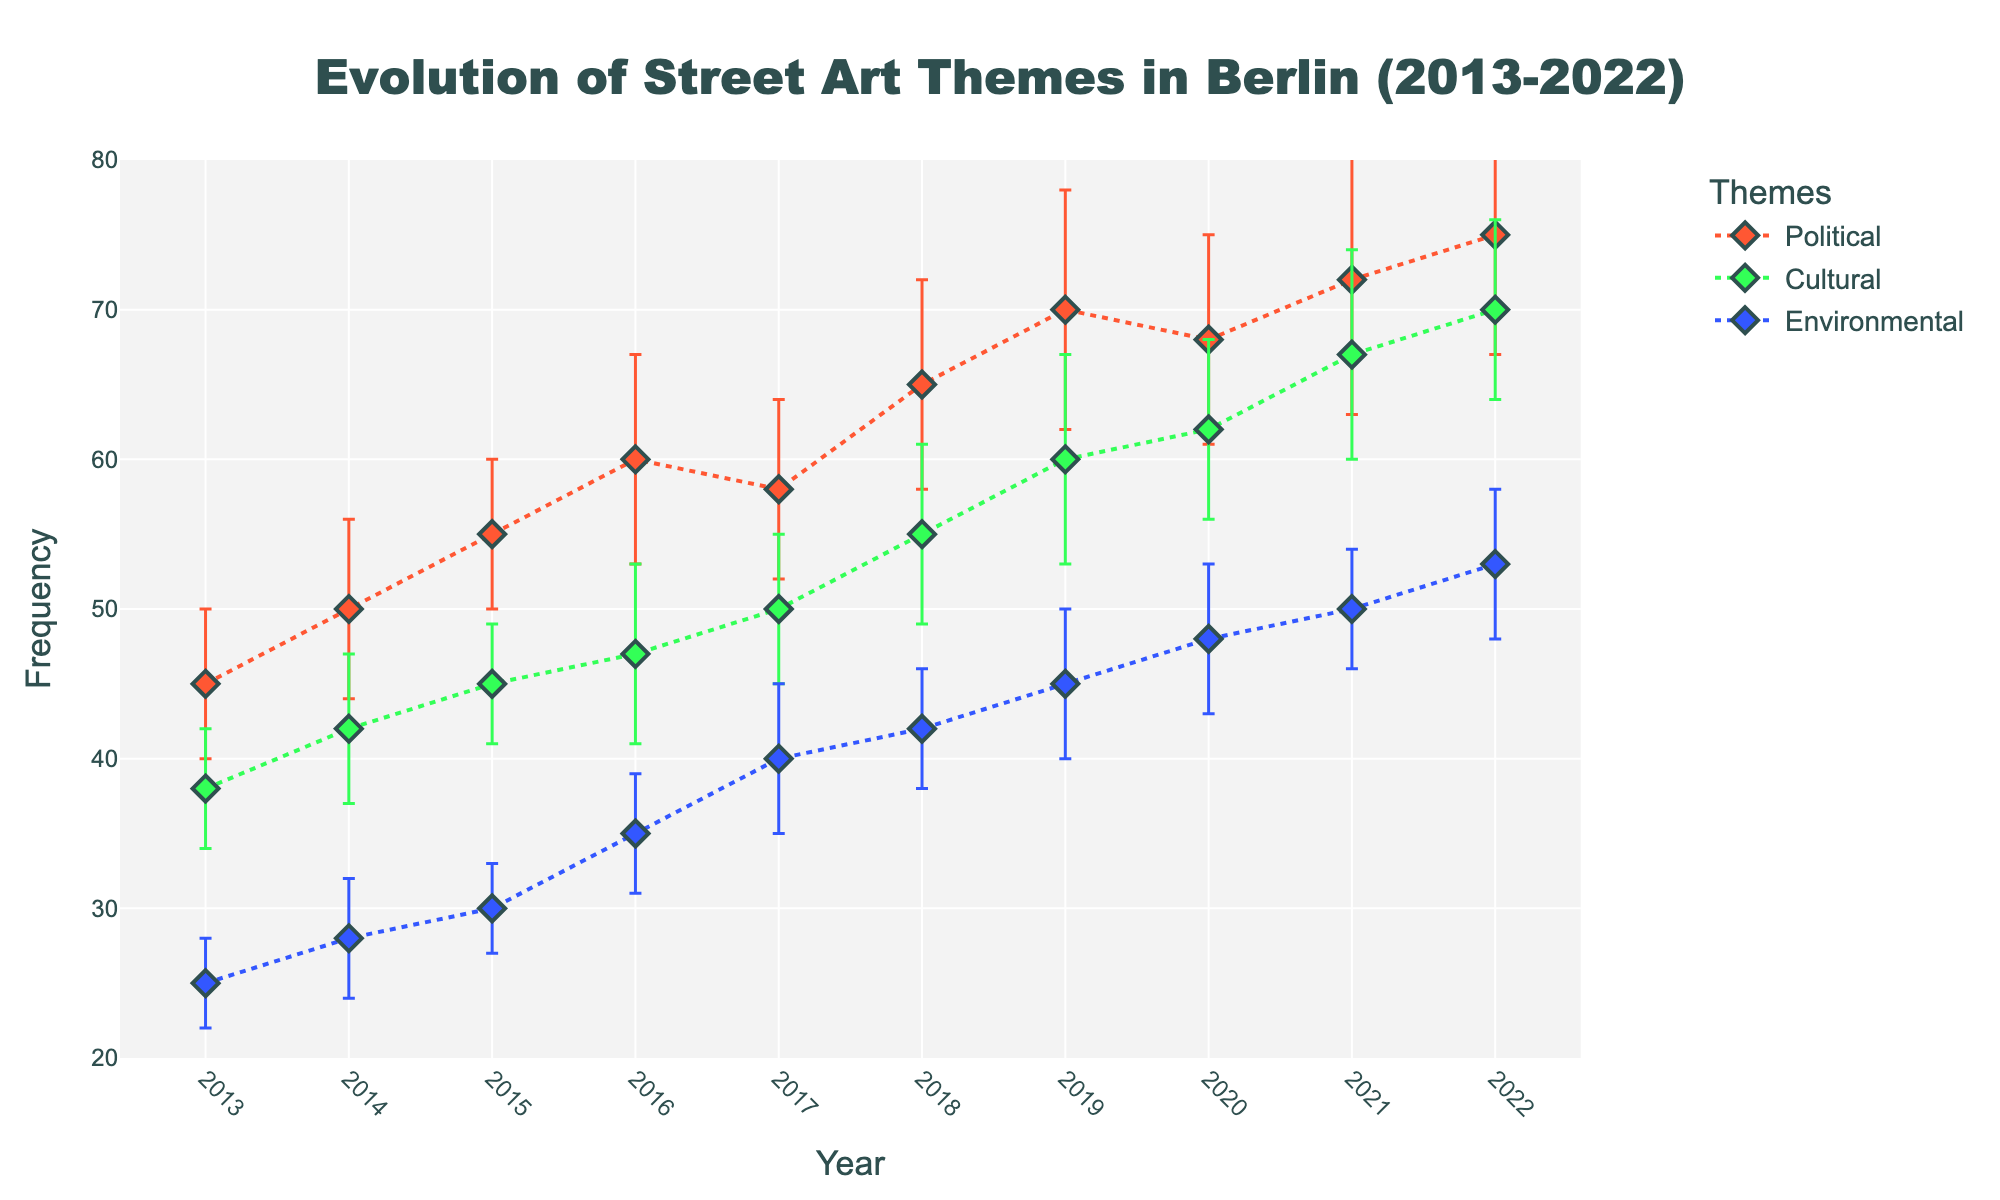What's the title of the plot? The title is usually displayed at the top of the plot. In this case, the title "Evolution of Street Art Themes in Berlin (2013-2022)" is centered and made bold to draw attention.
Answer: Evolution of Street Art Themes in Berlin (2013-2022) What are the three themes shown in the plot? The themes are indicated by different colors and are usually accompanied by a legend. Here, the themes are Political, Cultural, and Environmental, each represented with a different line and marker color.
Answer: Political, Cultural, Environmental Which year saw the highest frequency of Political-themed street art? Look at the Political data points and identify the year with the maximum value on the frequency axis. The highest frequency for Political-themed street art is found by finding the peak point along its line.
Answer: 2022 Between which years does the Cultural theme show the most significant increase? To find this, look at the changes in frequency between each pair of consecutive years for the Cultural theme. The steepest slope or largest difference indicates the most substantial increase.
Answer: 2021-2022 Which theme had the lowest starting frequency in 2013? Compare the frequencies of each theme at the year 2013. The one with the smallest value is the answer.
Answer: Environmental How many years does the plot cover for each theme? Look at the range on the x-axis. The plot spans from 2013 to 2022, so each theme is covered for the number of years in that range.
Answer: 10 years What is the overall trend of Environmental-themed street art over the decade? Observing the trend over the years for the Environmental theme, you can see whether it's generally increasing, decreasing, or remaining stable by following the slope of the line.
Answer: Increasing In which year did all themes see an increase compared to the previous year? To answer this, check year-to-year data points for each theme and see where frequencies for all three themes increase compared to the previous year.
Answer: 2014 For the Political theme, what is the minimum value plus its error bar in 2013? The frequency for Political in 2013 is 45. The error bar is 5, so add these together.
Answer: 50 Between 2017 and 2020, which theme had the most stable frequency (least variation)? By observing the error bars and overall changes in frequency from 2017 to 2020 for each theme, the one with the smallest fluctuation is the most stable.
Answer: Cultural 